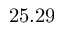<formula> <loc_0><loc_0><loc_500><loc_500>2 5 . 2 9</formula> 